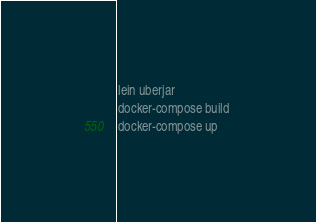<code> <loc_0><loc_0><loc_500><loc_500><_Bash_>lein uberjar 
docker-compose build 
docker-compose up
</code> 